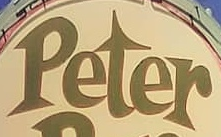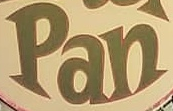Transcribe the words shown in these images in order, separated by a semicolon. Peter; Pan 